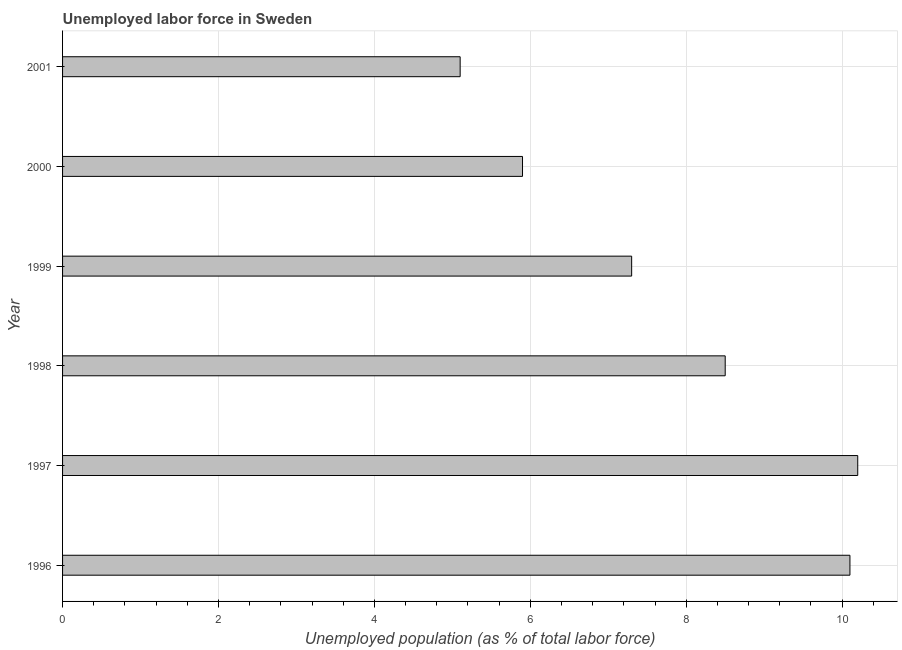Does the graph contain any zero values?
Your answer should be very brief. No. Does the graph contain grids?
Your response must be concise. Yes. What is the title of the graph?
Your response must be concise. Unemployed labor force in Sweden. What is the label or title of the X-axis?
Provide a short and direct response. Unemployed population (as % of total labor force). What is the total unemployed population in 1996?
Offer a very short reply. 10.1. Across all years, what is the maximum total unemployed population?
Ensure brevity in your answer.  10.2. Across all years, what is the minimum total unemployed population?
Your answer should be compact. 5.1. In which year was the total unemployed population maximum?
Make the answer very short. 1997. In which year was the total unemployed population minimum?
Your response must be concise. 2001. What is the sum of the total unemployed population?
Provide a short and direct response. 47.1. What is the difference between the total unemployed population in 1996 and 1997?
Your response must be concise. -0.1. What is the average total unemployed population per year?
Your answer should be compact. 7.85. What is the median total unemployed population?
Offer a terse response. 7.9. In how many years, is the total unemployed population greater than 7.6 %?
Keep it short and to the point. 3. Do a majority of the years between 1999 and 1996 (inclusive) have total unemployed population greater than 0.4 %?
Give a very brief answer. Yes. What is the ratio of the total unemployed population in 1998 to that in 1999?
Your answer should be very brief. 1.16. Is the difference between the total unemployed population in 1998 and 2000 greater than the difference between any two years?
Offer a very short reply. No. What is the difference between the highest and the second highest total unemployed population?
Your answer should be compact. 0.1. Is the sum of the total unemployed population in 1998 and 1999 greater than the maximum total unemployed population across all years?
Your answer should be very brief. Yes. In how many years, is the total unemployed population greater than the average total unemployed population taken over all years?
Your answer should be compact. 3. How many bars are there?
Offer a terse response. 6. How many years are there in the graph?
Ensure brevity in your answer.  6. Are the values on the major ticks of X-axis written in scientific E-notation?
Provide a short and direct response. No. What is the Unemployed population (as % of total labor force) of 1996?
Your response must be concise. 10.1. What is the Unemployed population (as % of total labor force) of 1997?
Give a very brief answer. 10.2. What is the Unemployed population (as % of total labor force) in 1999?
Keep it short and to the point. 7.3. What is the Unemployed population (as % of total labor force) of 2000?
Give a very brief answer. 5.9. What is the Unemployed population (as % of total labor force) of 2001?
Your answer should be very brief. 5.1. What is the difference between the Unemployed population (as % of total labor force) in 1996 and 1997?
Keep it short and to the point. -0.1. What is the difference between the Unemployed population (as % of total labor force) in 1996 and 1999?
Offer a terse response. 2.8. What is the difference between the Unemployed population (as % of total labor force) in 1996 and 2000?
Provide a succinct answer. 4.2. What is the difference between the Unemployed population (as % of total labor force) in 1997 and 1999?
Keep it short and to the point. 2.9. What is the difference between the Unemployed population (as % of total labor force) in 1998 and 1999?
Provide a short and direct response. 1.2. What is the difference between the Unemployed population (as % of total labor force) in 1998 and 2000?
Keep it short and to the point. 2.6. What is the difference between the Unemployed population (as % of total labor force) in 1998 and 2001?
Keep it short and to the point. 3.4. What is the difference between the Unemployed population (as % of total labor force) in 2000 and 2001?
Your answer should be very brief. 0.8. What is the ratio of the Unemployed population (as % of total labor force) in 1996 to that in 1998?
Your answer should be compact. 1.19. What is the ratio of the Unemployed population (as % of total labor force) in 1996 to that in 1999?
Offer a terse response. 1.38. What is the ratio of the Unemployed population (as % of total labor force) in 1996 to that in 2000?
Keep it short and to the point. 1.71. What is the ratio of the Unemployed population (as % of total labor force) in 1996 to that in 2001?
Ensure brevity in your answer.  1.98. What is the ratio of the Unemployed population (as % of total labor force) in 1997 to that in 1998?
Provide a succinct answer. 1.2. What is the ratio of the Unemployed population (as % of total labor force) in 1997 to that in 1999?
Ensure brevity in your answer.  1.4. What is the ratio of the Unemployed population (as % of total labor force) in 1997 to that in 2000?
Your answer should be compact. 1.73. What is the ratio of the Unemployed population (as % of total labor force) in 1997 to that in 2001?
Ensure brevity in your answer.  2. What is the ratio of the Unemployed population (as % of total labor force) in 1998 to that in 1999?
Provide a succinct answer. 1.16. What is the ratio of the Unemployed population (as % of total labor force) in 1998 to that in 2000?
Make the answer very short. 1.44. What is the ratio of the Unemployed population (as % of total labor force) in 1998 to that in 2001?
Provide a short and direct response. 1.67. What is the ratio of the Unemployed population (as % of total labor force) in 1999 to that in 2000?
Keep it short and to the point. 1.24. What is the ratio of the Unemployed population (as % of total labor force) in 1999 to that in 2001?
Provide a short and direct response. 1.43. What is the ratio of the Unemployed population (as % of total labor force) in 2000 to that in 2001?
Your answer should be compact. 1.16. 